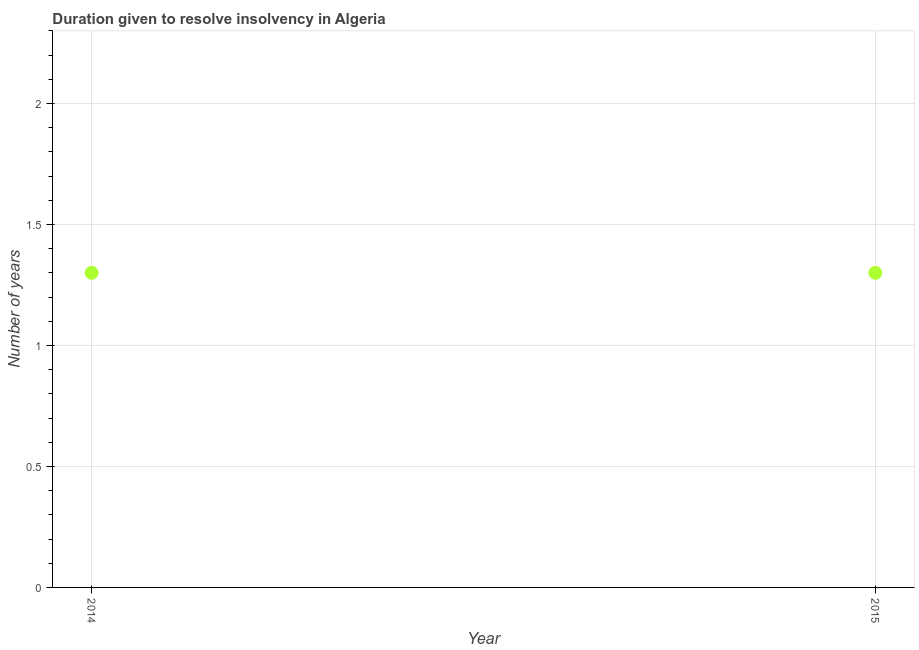Across all years, what is the maximum number of years to resolve insolvency?
Give a very brief answer. 1.3. Across all years, what is the minimum number of years to resolve insolvency?
Your answer should be very brief. 1.3. In which year was the number of years to resolve insolvency maximum?
Make the answer very short. 2014. In which year was the number of years to resolve insolvency minimum?
Make the answer very short. 2014. What is the difference between the number of years to resolve insolvency in 2014 and 2015?
Offer a very short reply. 0. What is the average number of years to resolve insolvency per year?
Your answer should be compact. 1.3. What is the median number of years to resolve insolvency?
Give a very brief answer. 1.3. In how many years, is the number of years to resolve insolvency greater than 1.8 ?
Your answer should be very brief. 0. Do a majority of the years between 2015 and 2014 (inclusive) have number of years to resolve insolvency greater than 1.1 ?
Your answer should be compact. No. What is the ratio of the number of years to resolve insolvency in 2014 to that in 2015?
Keep it short and to the point. 1. What is the difference between two consecutive major ticks on the Y-axis?
Your answer should be very brief. 0.5. Does the graph contain any zero values?
Offer a very short reply. No. What is the title of the graph?
Keep it short and to the point. Duration given to resolve insolvency in Algeria. What is the label or title of the X-axis?
Offer a terse response. Year. What is the label or title of the Y-axis?
Make the answer very short. Number of years. What is the Number of years in 2014?
Your response must be concise. 1.3. What is the difference between the Number of years in 2014 and 2015?
Give a very brief answer. 0. 